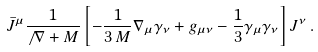Convert formula to latex. <formula><loc_0><loc_0><loc_500><loc_500>\bar { J } ^ { \mu } \frac { 1 } { \not \, \nabla + M } \left [ - \frac { 1 } { 3 \, M } \nabla _ { \mu } \gamma _ { \nu } + g _ { \mu \nu } - \frac { 1 } { 3 } \gamma _ { \mu } \gamma _ { \nu } \right ] J ^ { \nu } \, .</formula> 